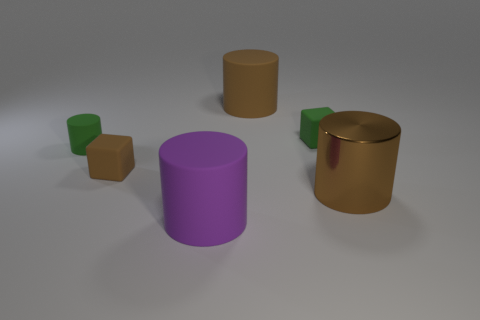Add 3 tiny cylinders. How many objects exist? 9 Subtract all shiny cylinders. How many cylinders are left? 3 Subtract 1 green cubes. How many objects are left? 5 Subtract all cylinders. How many objects are left? 2 Subtract 1 cubes. How many cubes are left? 1 Subtract all gray cylinders. Subtract all purple cubes. How many cylinders are left? 4 Subtract all cyan blocks. How many brown cylinders are left? 2 Subtract all large purple cylinders. Subtract all tiny matte cylinders. How many objects are left? 4 Add 1 green cylinders. How many green cylinders are left? 2 Add 5 large shiny objects. How many large shiny objects exist? 6 